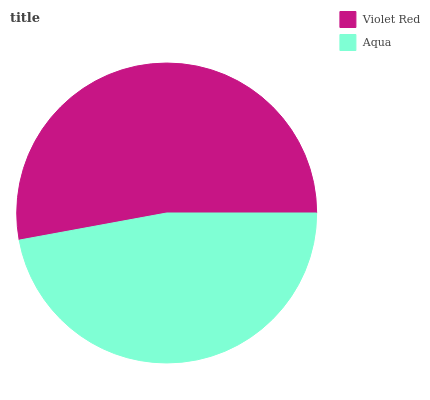Is Aqua the minimum?
Answer yes or no. Yes. Is Violet Red the maximum?
Answer yes or no. Yes. Is Aqua the maximum?
Answer yes or no. No. Is Violet Red greater than Aqua?
Answer yes or no. Yes. Is Aqua less than Violet Red?
Answer yes or no. Yes. Is Aqua greater than Violet Red?
Answer yes or no. No. Is Violet Red less than Aqua?
Answer yes or no. No. Is Violet Red the high median?
Answer yes or no. Yes. Is Aqua the low median?
Answer yes or no. Yes. Is Aqua the high median?
Answer yes or no. No. Is Violet Red the low median?
Answer yes or no. No. 